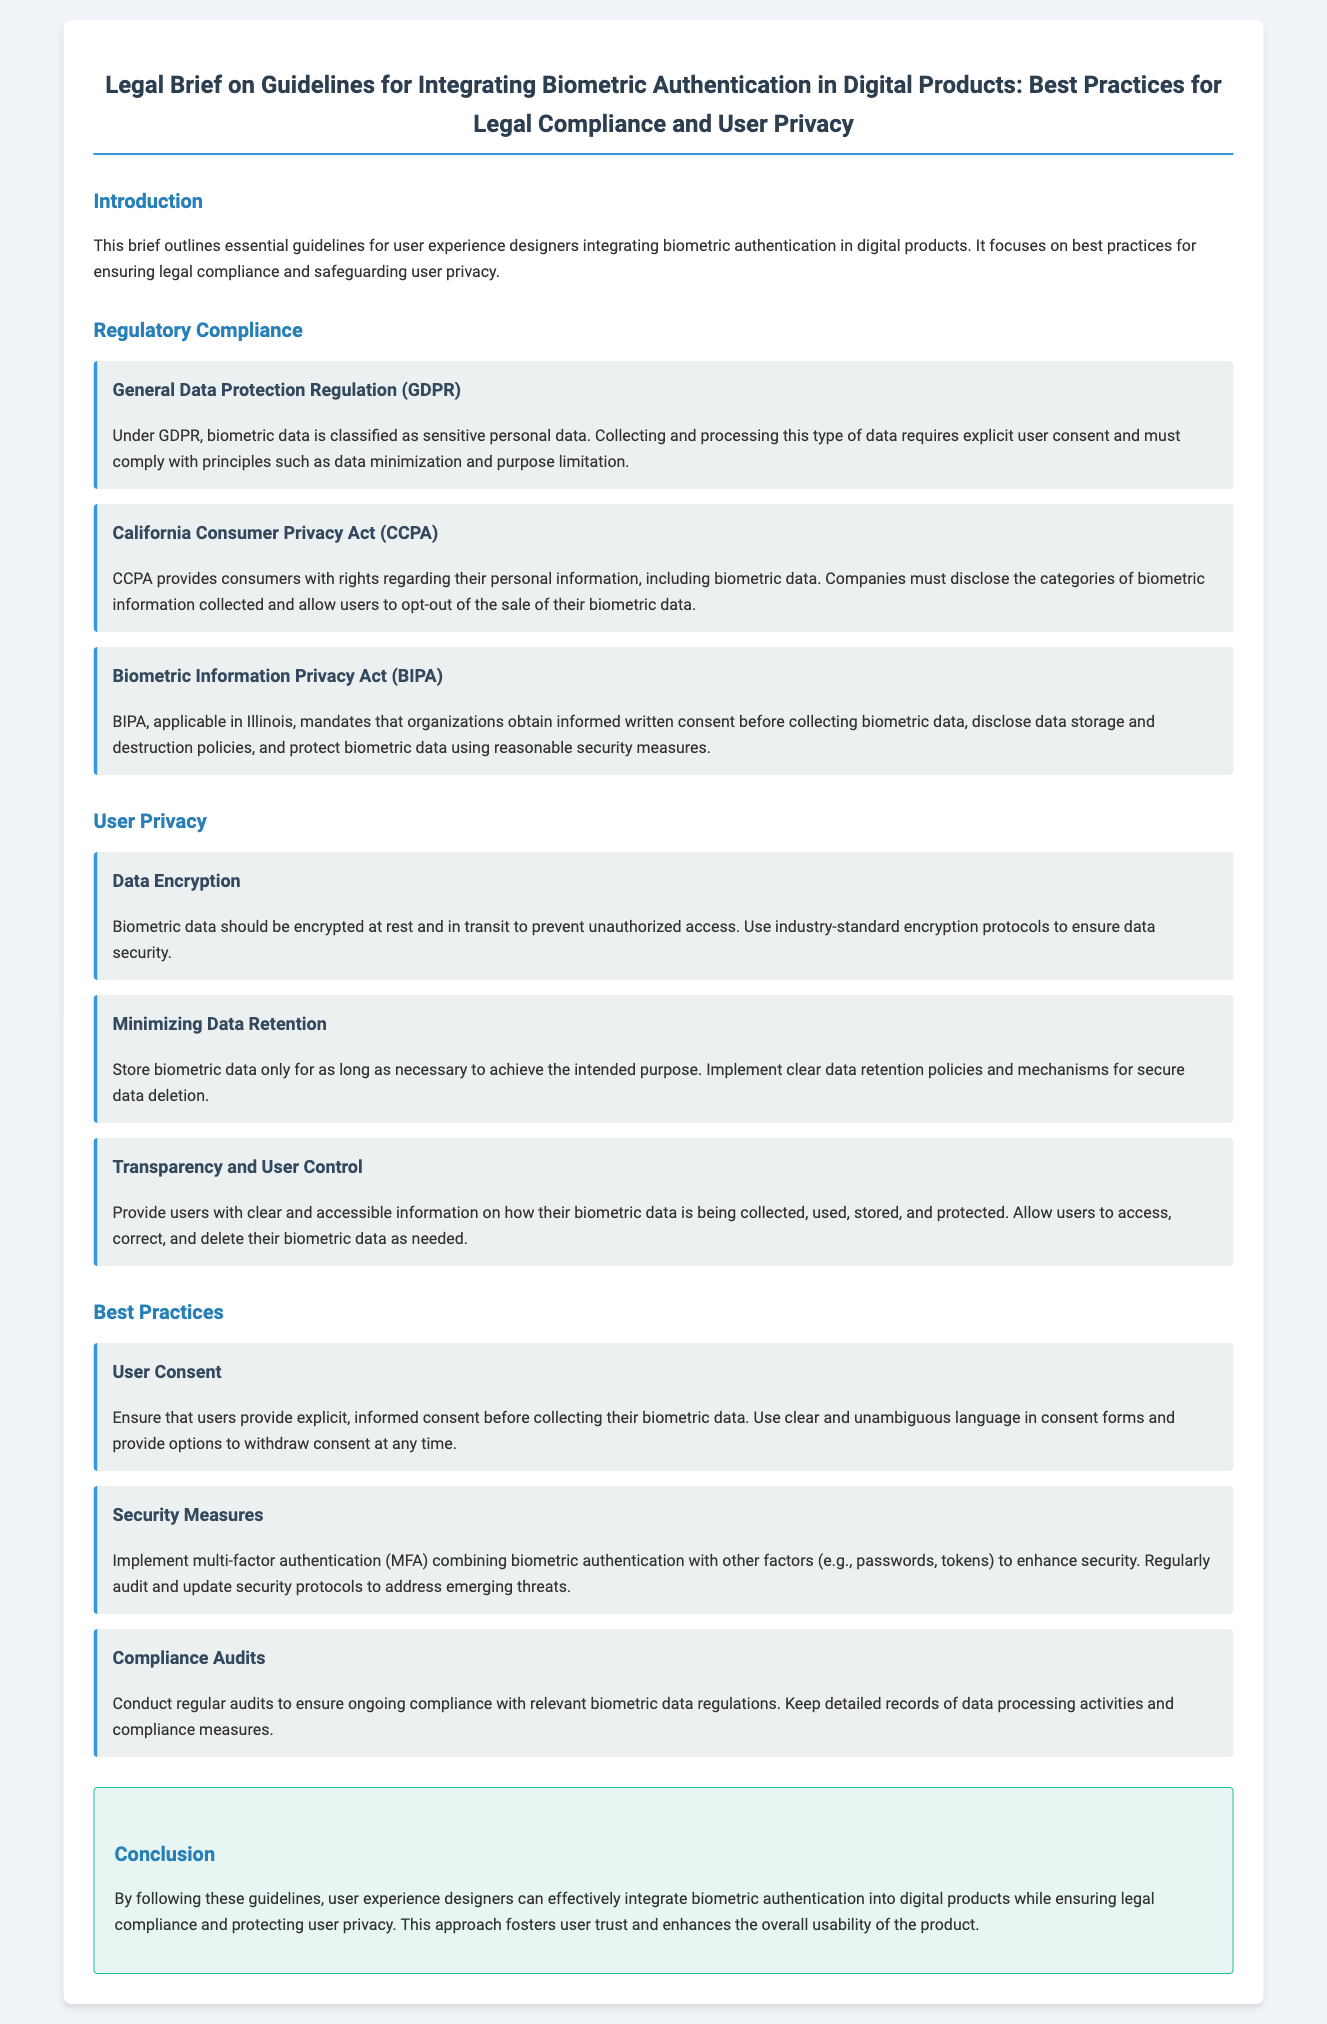What is the main focus of the brief? The main focus of the brief is to provide guidelines for user experience designers integrating biometric authentication, emphasizing legal compliance and user privacy.
Answer: Guidelines for user experience designers integrating biometric authentication, emphasizing legal compliance and user privacy What does GDPR classify biometric data as? GDPR classifies biometric data as sensitive personal data, which requires explicit user consent for collection and processing.
Answer: Sensitive personal data What is one requirement of the California Consumer Privacy Act regarding biometric data? CCPA requires companies to disclose the categories of biometric information collected and allow users to opt-out of the sale of their biometric data.
Answer: Disclose the categories of biometric information collected What is mandated by the Biometric Information Privacy Act before collecting biometric data? BIPA mandates that organizations obtain informed written consent before collecting biometric data.
Answer: Informed written consent What security practice should be implemented alongside biometric authentication? Multi-factor authentication combining biometric authentication with other factors (e.g., passwords, tokens) should be implemented to enhance security.
Answer: Multi-factor authentication What is recommended for the retention of biometric data? It is recommended to store biometric data only for as long as necessary to achieve the intended purpose and to implement clear data retention policies.
Answer: Store data only as long as necessary What should users be provided regarding their biometric data? Users should be provided with clear and accessible information on how their biometric data is being collected, used, stored, and protected.
Answer: Clear and accessible information How often should compliance audits be conducted? Regular audits should be conducted to ensure ongoing compliance with relevant biometric data regulations.
Answer: Regularly What is the result of following the guidelines in the brief? Following the guidelines fosters user trust and enhances the overall usability of the product.
Answer: Fosters user trust and enhances usability 